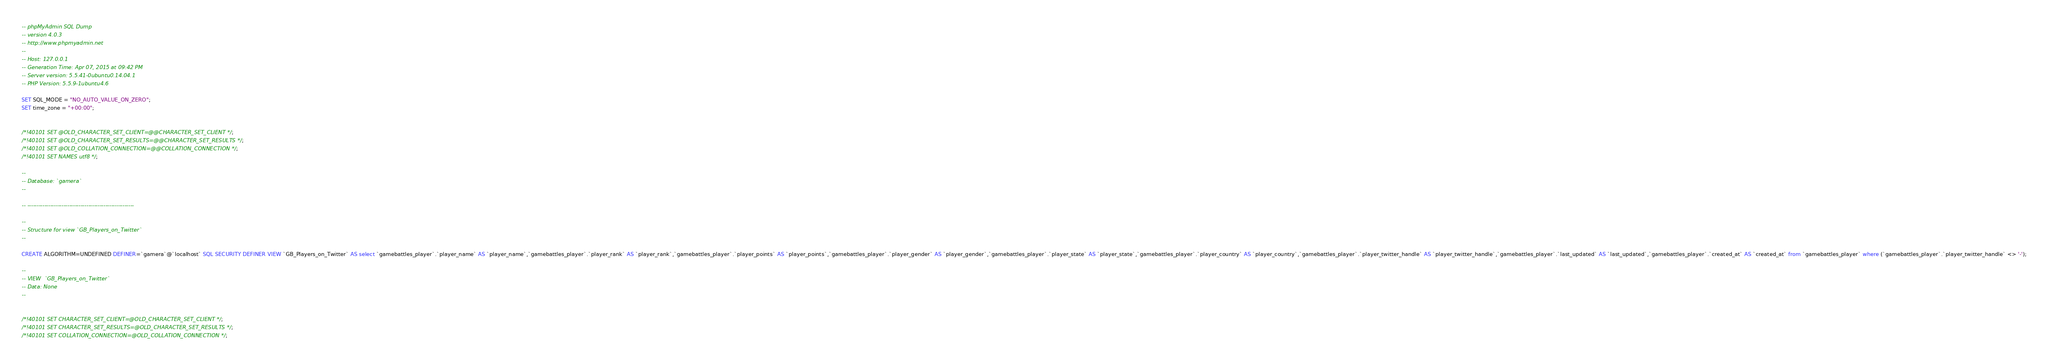Convert code to text. <code><loc_0><loc_0><loc_500><loc_500><_SQL_>-- phpMyAdmin SQL Dump
-- version 4.0.3
-- http://www.phpmyadmin.net
--
-- Host: 127.0.0.1
-- Generation Time: Apr 07, 2015 at 09:42 PM
-- Server version: 5.5.41-0ubuntu0.14.04.1
-- PHP Version: 5.5.9-1ubuntu4.6

SET SQL_MODE = "NO_AUTO_VALUE_ON_ZERO";
SET time_zone = "+00:00";


/*!40101 SET @OLD_CHARACTER_SET_CLIENT=@@CHARACTER_SET_CLIENT */;
/*!40101 SET @OLD_CHARACTER_SET_RESULTS=@@CHARACTER_SET_RESULTS */;
/*!40101 SET @OLD_COLLATION_CONNECTION=@@COLLATION_CONNECTION */;
/*!40101 SET NAMES utf8 */;

--
-- Database: `gamera`
--

-- --------------------------------------------------------

--
-- Structure for view `GB_Players_on_Twitter`
--

CREATE ALGORITHM=UNDEFINED DEFINER=`gamera`@`localhost` SQL SECURITY DEFINER VIEW `GB_Players_on_Twitter` AS select `gamebattles_player`.`player_name` AS `player_name`,`gamebattles_player`.`player_rank` AS `player_rank`,`gamebattles_player`.`player_points` AS `player_points`,`gamebattles_player`.`player_gender` AS `player_gender`,`gamebattles_player`.`player_state` AS `player_state`,`gamebattles_player`.`player_country` AS `player_country`,`gamebattles_player`.`player_twitter_handle` AS `player_twitter_handle`,`gamebattles_player`.`last_updated` AS `last_updated`,`gamebattles_player`.`created_at` AS `created_at` from `gamebattles_player` where (`gamebattles_player`.`player_twitter_handle` <> '-');

--
-- VIEW  `GB_Players_on_Twitter`
-- Data: None
--


/*!40101 SET CHARACTER_SET_CLIENT=@OLD_CHARACTER_SET_CLIENT */;
/*!40101 SET CHARACTER_SET_RESULTS=@OLD_CHARACTER_SET_RESULTS */;
/*!40101 SET COLLATION_CONNECTION=@OLD_COLLATION_CONNECTION */;
</code> 